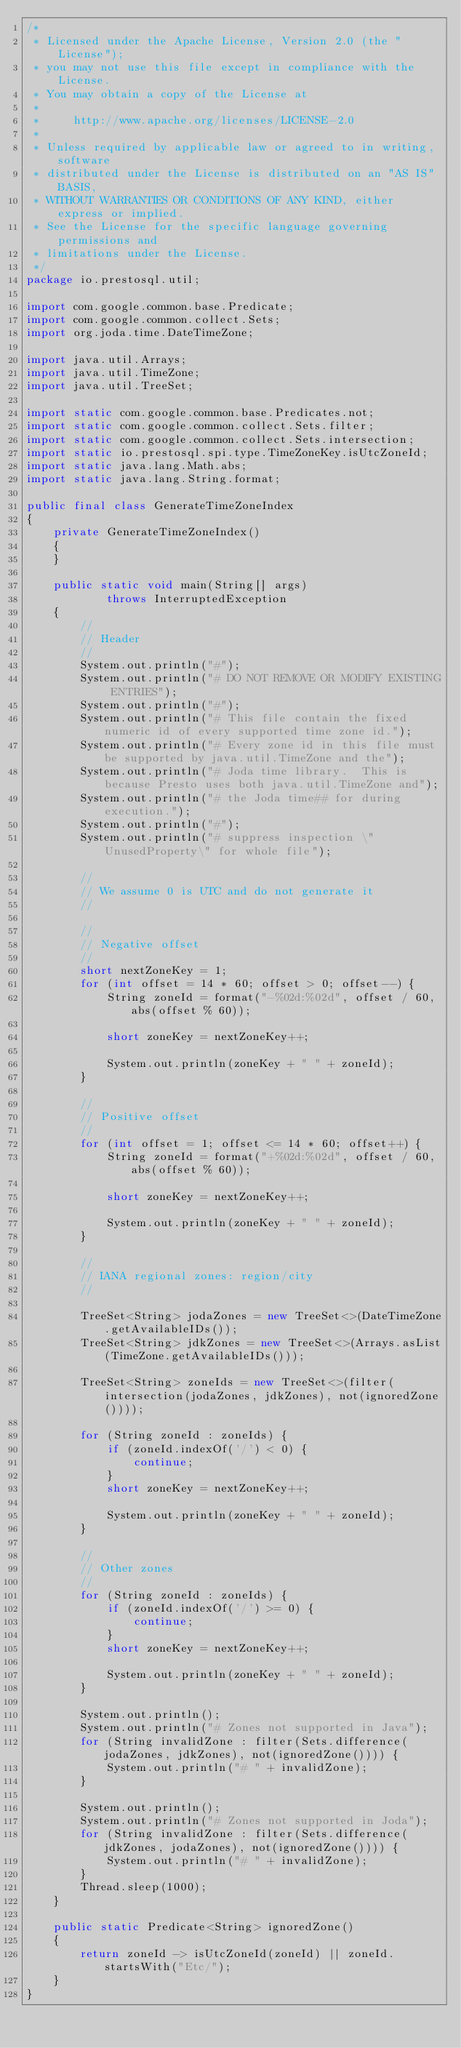Convert code to text. <code><loc_0><loc_0><loc_500><loc_500><_Java_>/*
 * Licensed under the Apache License, Version 2.0 (the "License");
 * you may not use this file except in compliance with the License.
 * You may obtain a copy of the License at
 *
 *     http://www.apache.org/licenses/LICENSE-2.0
 *
 * Unless required by applicable law or agreed to in writing, software
 * distributed under the License is distributed on an "AS IS" BASIS,
 * WITHOUT WARRANTIES OR CONDITIONS OF ANY KIND, either express or implied.
 * See the License for the specific language governing permissions and
 * limitations under the License.
 */
package io.prestosql.util;

import com.google.common.base.Predicate;
import com.google.common.collect.Sets;
import org.joda.time.DateTimeZone;

import java.util.Arrays;
import java.util.TimeZone;
import java.util.TreeSet;

import static com.google.common.base.Predicates.not;
import static com.google.common.collect.Sets.filter;
import static com.google.common.collect.Sets.intersection;
import static io.prestosql.spi.type.TimeZoneKey.isUtcZoneId;
import static java.lang.Math.abs;
import static java.lang.String.format;

public final class GenerateTimeZoneIndex
{
    private GenerateTimeZoneIndex()
    {
    }

    public static void main(String[] args)
            throws InterruptedException
    {
        //
        // Header
        //
        System.out.println("#");
        System.out.println("# DO NOT REMOVE OR MODIFY EXISTING ENTRIES");
        System.out.println("#");
        System.out.println("# This file contain the fixed numeric id of every supported time zone id.");
        System.out.println("# Every zone id in this file must be supported by java.util.TimeZone and the");
        System.out.println("# Joda time library.  This is because Presto uses both java.util.TimeZone and");
        System.out.println("# the Joda time## for during execution.");
        System.out.println("#");
        System.out.println("# suppress inspection \"UnusedProperty\" for whole file");

        //
        // We assume 0 is UTC and do not generate it
        //

        //
        // Negative offset
        //
        short nextZoneKey = 1;
        for (int offset = 14 * 60; offset > 0; offset--) {
            String zoneId = format("-%02d:%02d", offset / 60, abs(offset % 60));

            short zoneKey = nextZoneKey++;

            System.out.println(zoneKey + " " + zoneId);
        }

        //
        // Positive offset
        //
        for (int offset = 1; offset <= 14 * 60; offset++) {
            String zoneId = format("+%02d:%02d", offset / 60, abs(offset % 60));

            short zoneKey = nextZoneKey++;

            System.out.println(zoneKey + " " + zoneId);
        }

        //
        // IANA regional zones: region/city
        //

        TreeSet<String> jodaZones = new TreeSet<>(DateTimeZone.getAvailableIDs());
        TreeSet<String> jdkZones = new TreeSet<>(Arrays.asList(TimeZone.getAvailableIDs()));

        TreeSet<String> zoneIds = new TreeSet<>(filter(intersection(jodaZones, jdkZones), not(ignoredZone())));

        for (String zoneId : zoneIds) {
            if (zoneId.indexOf('/') < 0) {
                continue;
            }
            short zoneKey = nextZoneKey++;

            System.out.println(zoneKey + " " + zoneId);
        }

        //
        // Other zones
        //
        for (String zoneId : zoneIds) {
            if (zoneId.indexOf('/') >= 0) {
                continue;
            }
            short zoneKey = nextZoneKey++;

            System.out.println(zoneKey + " " + zoneId);
        }

        System.out.println();
        System.out.println("# Zones not supported in Java");
        for (String invalidZone : filter(Sets.difference(jodaZones, jdkZones), not(ignoredZone()))) {
            System.out.println("# " + invalidZone);
        }

        System.out.println();
        System.out.println("# Zones not supported in Joda");
        for (String invalidZone : filter(Sets.difference(jdkZones, jodaZones), not(ignoredZone()))) {
            System.out.println("# " + invalidZone);
        }
        Thread.sleep(1000);
    }

    public static Predicate<String> ignoredZone()
    {
        return zoneId -> isUtcZoneId(zoneId) || zoneId.startsWith("Etc/");
    }
}
</code> 